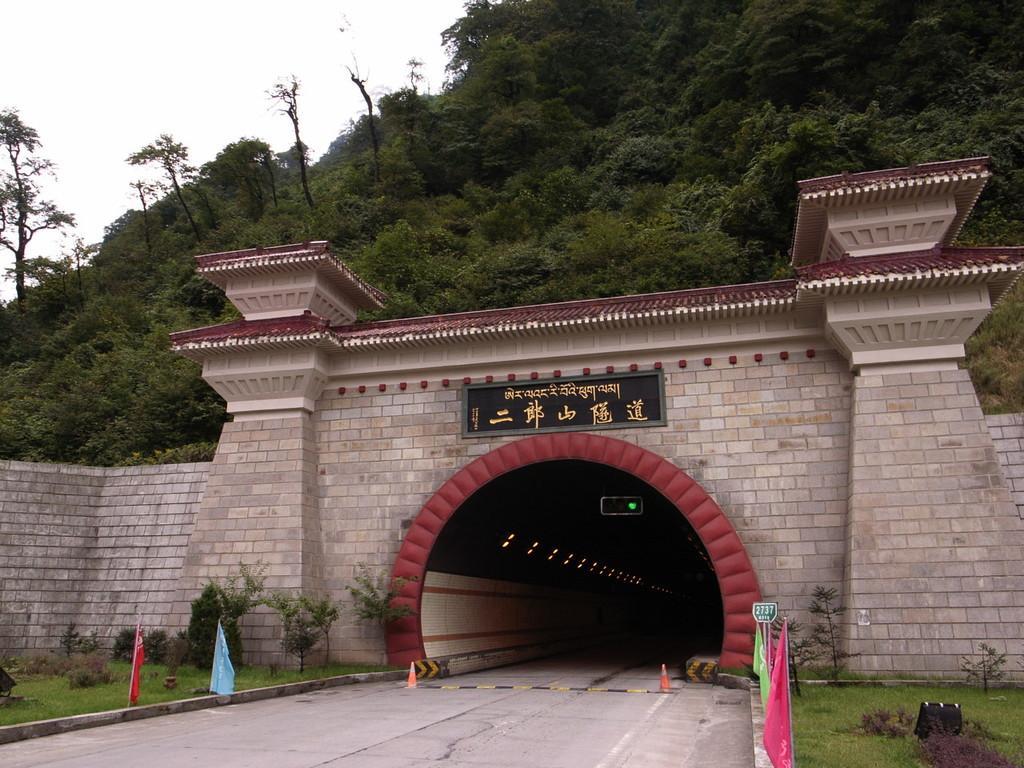Please provide a concise description of this image. In this picture I can see a brick wall, hill with some trees. 